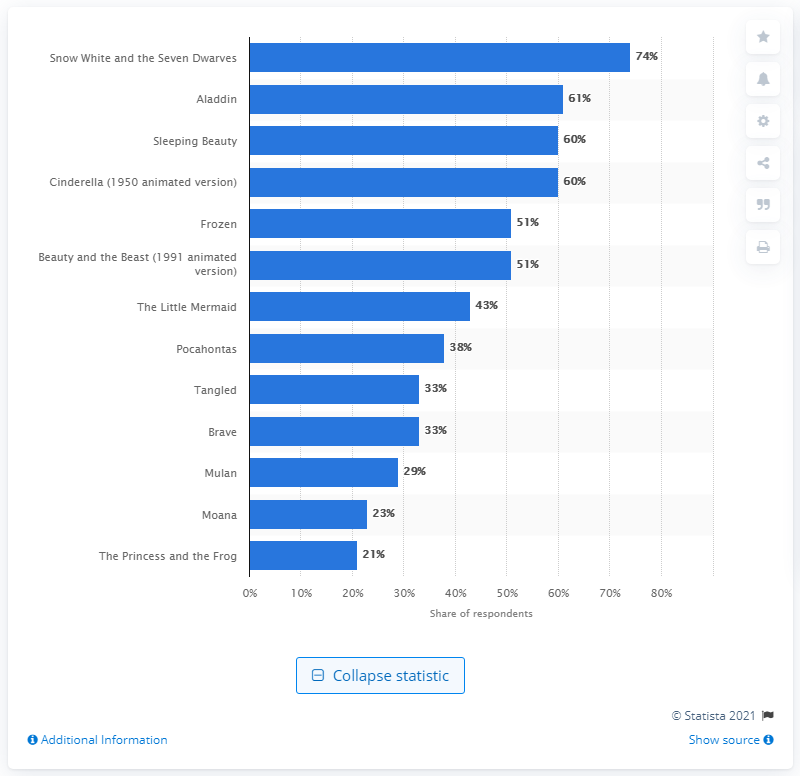Specify some key components in this picture. Snow White and the Seven Dwarves is the most well-known Disney princess movie. The second most watched movie featuring a Disney princess was "Aladdin. 